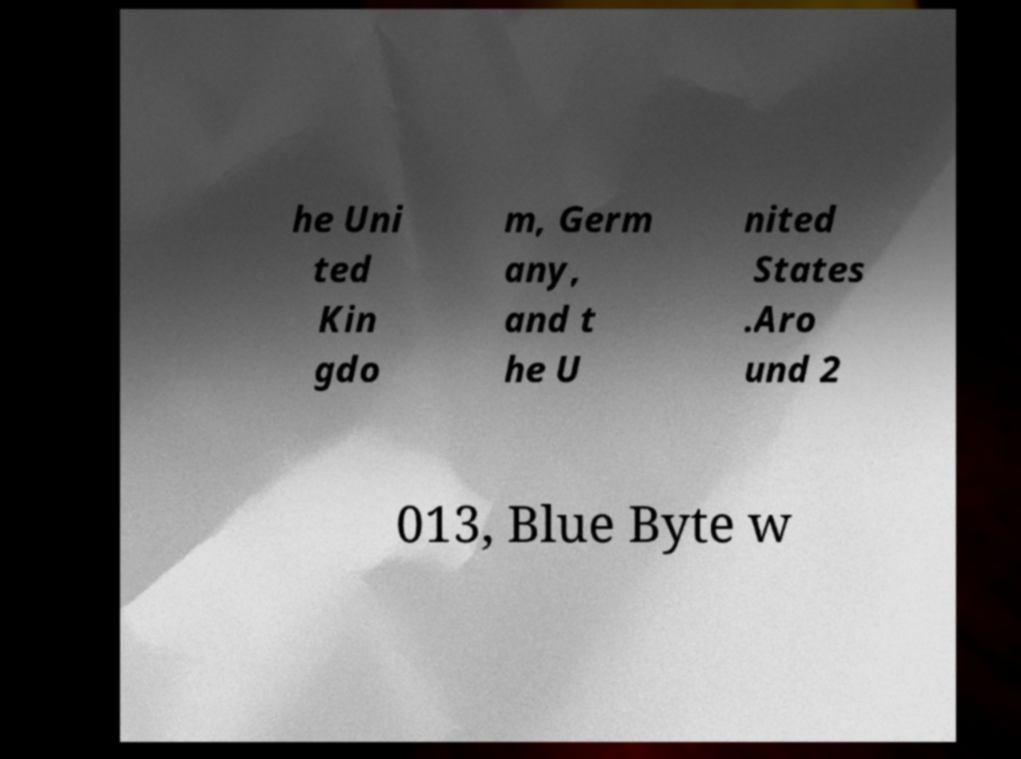Can you accurately transcribe the text from the provided image for me? he Uni ted Kin gdo m, Germ any, and t he U nited States .Aro und 2 013, Blue Byte w 